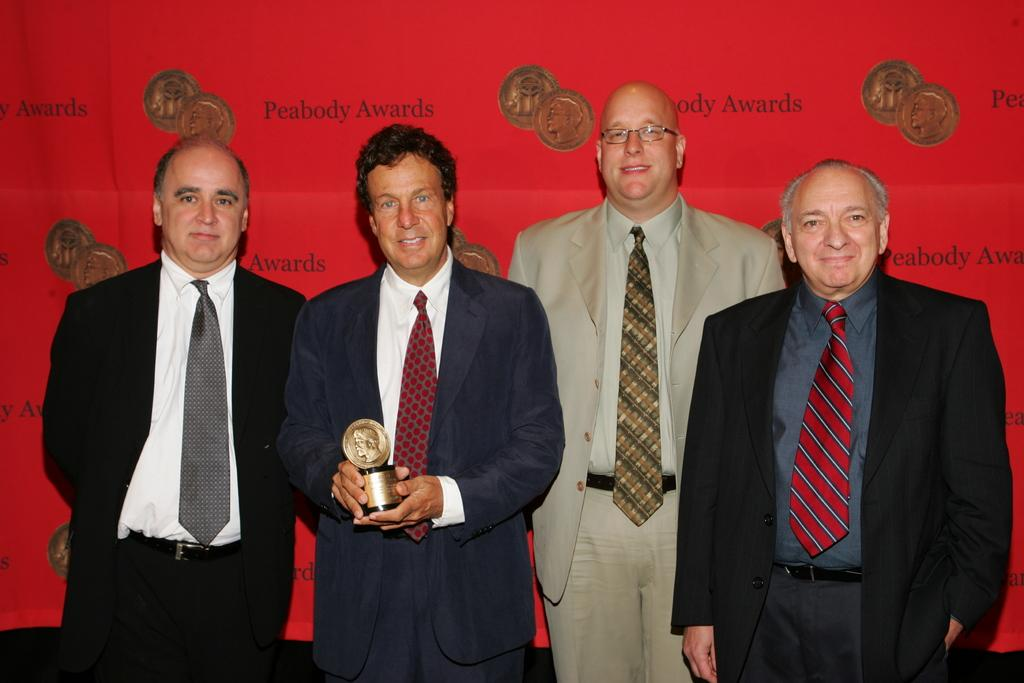What is the person in the center of the image holding? The person in the center of the image is holding an award. How are the other people in the image reacting to the person holding the award? The other people in the image are wearing smiles on their faces, suggesting they are happy for the person holding the award. Where are the other people in relation to the person holding the award? The other people are beside the person holding the award. What can be seen in the background of the image? There is a banner visible in the image, behind the people. What type of calculator can be seen on the banner in the image? There is no calculator present on the banner in the image. What hobbies do the people in the image have, based on their expressions? The expressions of the people in the image do not provide information about their hobbies; they are simply smiling. 